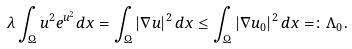Convert formula to latex. <formula><loc_0><loc_0><loc_500><loc_500>\lambda \int _ { \Omega } u ^ { 2 } e ^ { u ^ { 2 } } d x = \int _ { \Omega } | \nabla u | ^ { 2 } \, d x \leq \int _ { \Omega } | \nabla u _ { 0 } | ^ { 2 } \, d x = \colon \Lambda _ { 0 } .</formula> 